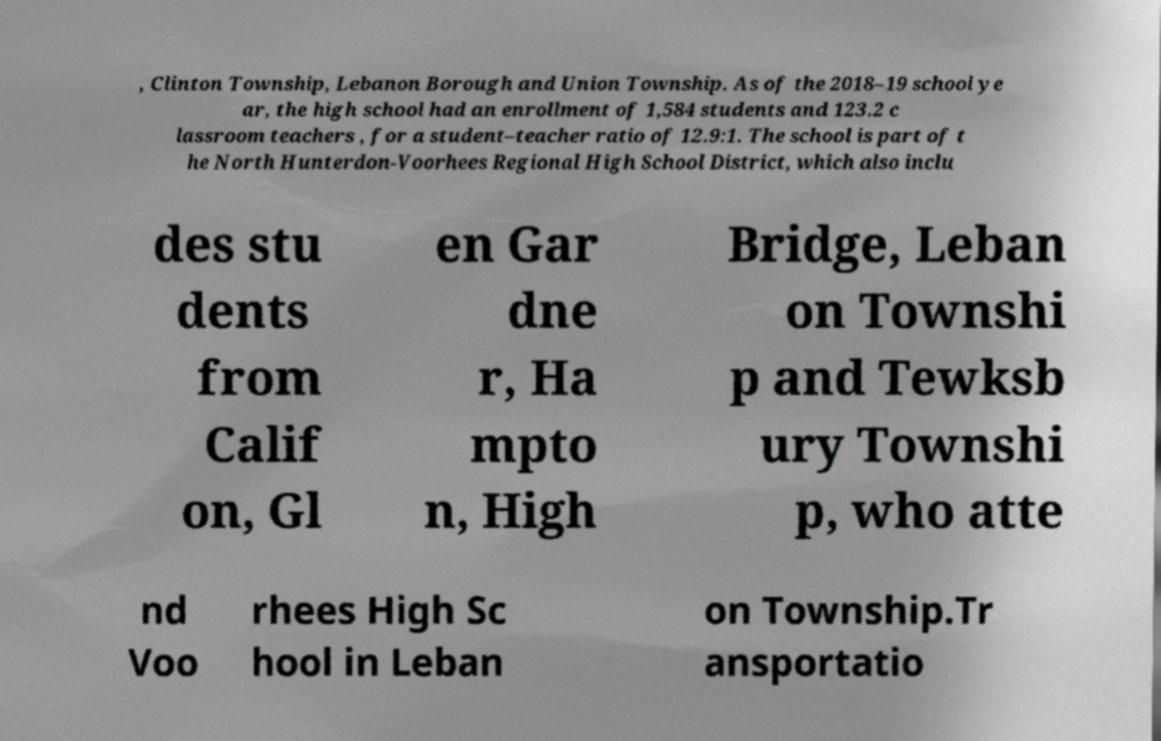Could you extract and type out the text from this image? , Clinton Township, Lebanon Borough and Union Township. As of the 2018–19 school ye ar, the high school had an enrollment of 1,584 students and 123.2 c lassroom teachers , for a student–teacher ratio of 12.9:1. The school is part of t he North Hunterdon-Voorhees Regional High School District, which also inclu des stu dents from Calif on, Gl en Gar dne r, Ha mpto n, High Bridge, Leban on Townshi p and Tewksb ury Townshi p, who atte nd Voo rhees High Sc hool in Leban on Township.Tr ansportatio 